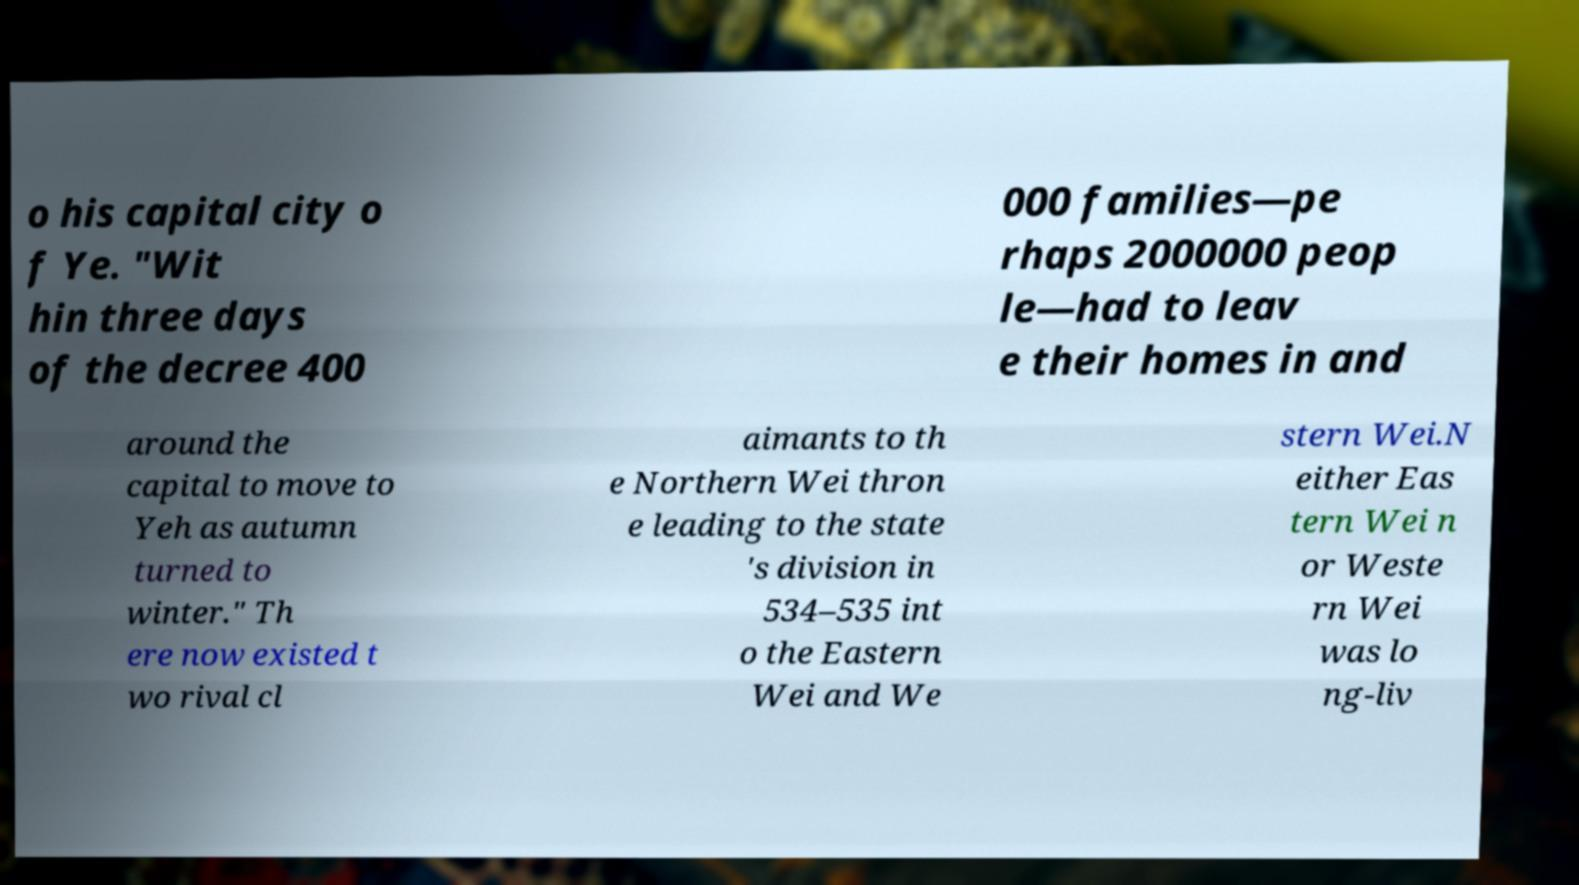There's text embedded in this image that I need extracted. Can you transcribe it verbatim? o his capital city o f Ye. "Wit hin three days of the decree 400 000 families—pe rhaps 2000000 peop le—had to leav e their homes in and around the capital to move to Yeh as autumn turned to winter." Th ere now existed t wo rival cl aimants to th e Northern Wei thron e leading to the state 's division in 534–535 int o the Eastern Wei and We stern Wei.N either Eas tern Wei n or Weste rn Wei was lo ng-liv 